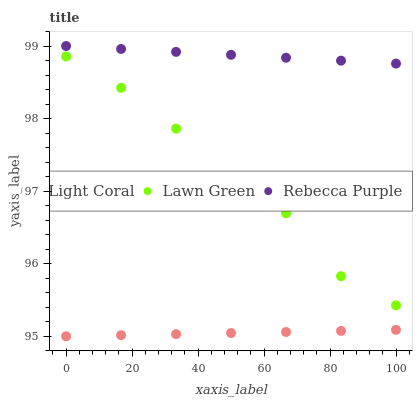Does Light Coral have the minimum area under the curve?
Answer yes or no. Yes. Does Rebecca Purple have the maximum area under the curve?
Answer yes or no. Yes. Does Lawn Green have the minimum area under the curve?
Answer yes or no. No. Does Lawn Green have the maximum area under the curve?
Answer yes or no. No. Is Light Coral the smoothest?
Answer yes or no. Yes. Is Lawn Green the roughest?
Answer yes or no. Yes. Is Rebecca Purple the smoothest?
Answer yes or no. No. Is Rebecca Purple the roughest?
Answer yes or no. No. Does Light Coral have the lowest value?
Answer yes or no. Yes. Does Lawn Green have the lowest value?
Answer yes or no. No. Does Rebecca Purple have the highest value?
Answer yes or no. Yes. Does Lawn Green have the highest value?
Answer yes or no. No. Is Light Coral less than Rebecca Purple?
Answer yes or no. Yes. Is Lawn Green greater than Light Coral?
Answer yes or no. Yes. Does Light Coral intersect Rebecca Purple?
Answer yes or no. No. 